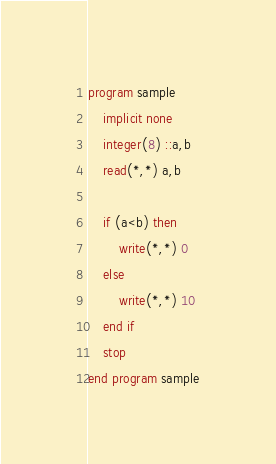<code> <loc_0><loc_0><loc_500><loc_500><_FORTRAN_>program sample
	implicit none
    integer(8) ::a,b
    read(*,*) a,b
    
    if (a<b) then
    	write(*,*) 0
    else
    	write(*,*) 10
    end if
    stop
end program sample</code> 